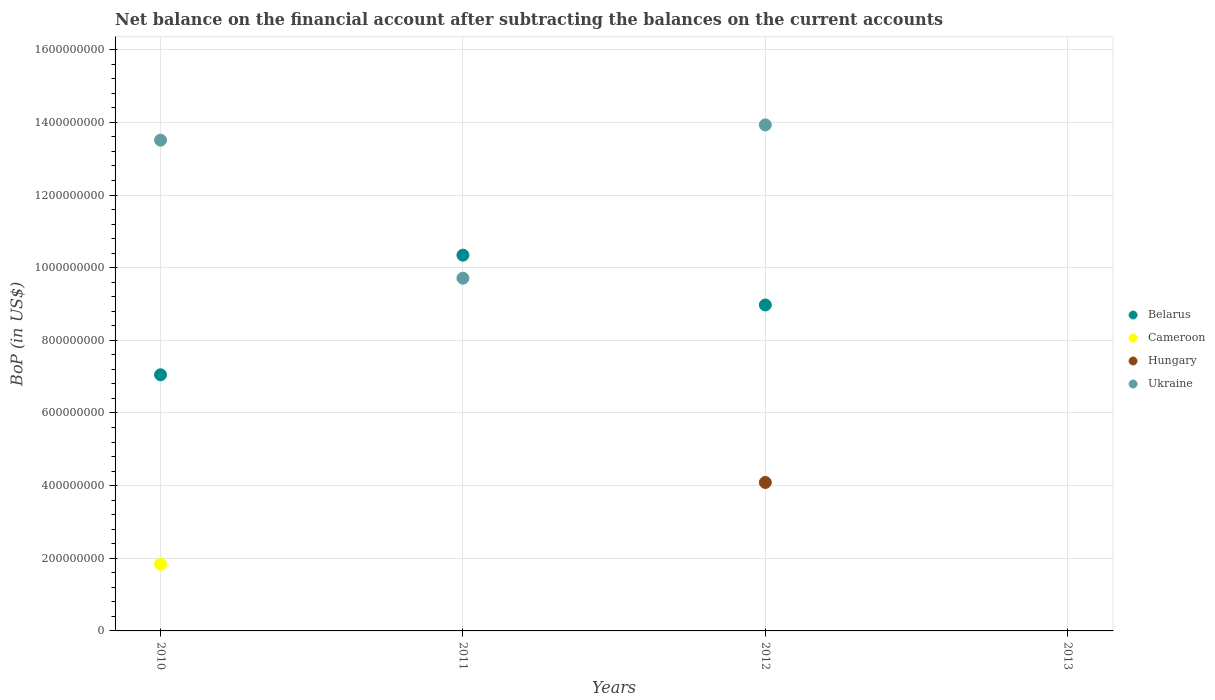What is the Balance of Payments in Hungary in 2010?
Your response must be concise. 0. Across all years, what is the maximum Balance of Payments in Cameroon?
Give a very brief answer. 1.84e+08. What is the total Balance of Payments in Belarus in the graph?
Offer a very short reply. 2.64e+09. What is the difference between the Balance of Payments in Ukraine in 2010 and that in 2011?
Your response must be concise. 3.80e+08. What is the difference between the Balance of Payments in Hungary in 2010 and the Balance of Payments in Belarus in 2012?
Offer a very short reply. -8.97e+08. What is the average Balance of Payments in Hungary per year?
Your response must be concise. 1.02e+08. In the year 2012, what is the difference between the Balance of Payments in Ukraine and Balance of Payments in Belarus?
Your answer should be compact. 4.96e+08. In how many years, is the Balance of Payments in Ukraine greater than 560000000 US$?
Keep it short and to the point. 3. Is the difference between the Balance of Payments in Ukraine in 2010 and 2012 greater than the difference between the Balance of Payments in Belarus in 2010 and 2012?
Give a very brief answer. Yes. What is the difference between the highest and the second highest Balance of Payments in Belarus?
Make the answer very short. 1.37e+08. What is the difference between the highest and the lowest Balance of Payments in Ukraine?
Give a very brief answer. 1.39e+09. Is the sum of the Balance of Payments in Ukraine in 2011 and 2012 greater than the maximum Balance of Payments in Belarus across all years?
Give a very brief answer. Yes. Does the Balance of Payments in Hungary monotonically increase over the years?
Keep it short and to the point. No. Is the Balance of Payments in Belarus strictly less than the Balance of Payments in Cameroon over the years?
Offer a very short reply. No. What is the difference between two consecutive major ticks on the Y-axis?
Ensure brevity in your answer.  2.00e+08. Are the values on the major ticks of Y-axis written in scientific E-notation?
Provide a short and direct response. No. Does the graph contain grids?
Provide a succinct answer. Yes. How many legend labels are there?
Ensure brevity in your answer.  4. What is the title of the graph?
Provide a short and direct response. Net balance on the financial account after subtracting the balances on the current accounts. Does "Suriname" appear as one of the legend labels in the graph?
Your response must be concise. No. What is the label or title of the X-axis?
Ensure brevity in your answer.  Years. What is the label or title of the Y-axis?
Your answer should be compact. BoP (in US$). What is the BoP (in US$) of Belarus in 2010?
Provide a short and direct response. 7.05e+08. What is the BoP (in US$) in Cameroon in 2010?
Provide a succinct answer. 1.84e+08. What is the BoP (in US$) of Hungary in 2010?
Ensure brevity in your answer.  0. What is the BoP (in US$) in Ukraine in 2010?
Keep it short and to the point. 1.35e+09. What is the BoP (in US$) in Belarus in 2011?
Keep it short and to the point. 1.03e+09. What is the BoP (in US$) of Cameroon in 2011?
Provide a short and direct response. 0. What is the BoP (in US$) in Ukraine in 2011?
Provide a succinct answer. 9.71e+08. What is the BoP (in US$) in Belarus in 2012?
Offer a very short reply. 8.97e+08. What is the BoP (in US$) in Hungary in 2012?
Ensure brevity in your answer.  4.09e+08. What is the BoP (in US$) of Ukraine in 2012?
Provide a succinct answer. 1.39e+09. What is the BoP (in US$) of Belarus in 2013?
Provide a succinct answer. 0. What is the BoP (in US$) of Cameroon in 2013?
Offer a very short reply. 0. What is the BoP (in US$) in Hungary in 2013?
Keep it short and to the point. 0. Across all years, what is the maximum BoP (in US$) in Belarus?
Offer a terse response. 1.03e+09. Across all years, what is the maximum BoP (in US$) in Cameroon?
Offer a very short reply. 1.84e+08. Across all years, what is the maximum BoP (in US$) in Hungary?
Provide a short and direct response. 4.09e+08. Across all years, what is the maximum BoP (in US$) in Ukraine?
Your answer should be compact. 1.39e+09. Across all years, what is the minimum BoP (in US$) in Belarus?
Offer a very short reply. 0. What is the total BoP (in US$) of Belarus in the graph?
Your answer should be very brief. 2.64e+09. What is the total BoP (in US$) of Cameroon in the graph?
Your answer should be very brief. 1.84e+08. What is the total BoP (in US$) in Hungary in the graph?
Give a very brief answer. 4.09e+08. What is the total BoP (in US$) of Ukraine in the graph?
Your answer should be compact. 3.72e+09. What is the difference between the BoP (in US$) in Belarus in 2010 and that in 2011?
Provide a succinct answer. -3.29e+08. What is the difference between the BoP (in US$) of Ukraine in 2010 and that in 2011?
Provide a succinct answer. 3.80e+08. What is the difference between the BoP (in US$) in Belarus in 2010 and that in 2012?
Provide a short and direct response. -1.92e+08. What is the difference between the BoP (in US$) in Ukraine in 2010 and that in 2012?
Ensure brevity in your answer.  -4.20e+07. What is the difference between the BoP (in US$) in Belarus in 2011 and that in 2012?
Your answer should be very brief. 1.37e+08. What is the difference between the BoP (in US$) of Ukraine in 2011 and that in 2012?
Offer a very short reply. -4.22e+08. What is the difference between the BoP (in US$) of Belarus in 2010 and the BoP (in US$) of Ukraine in 2011?
Give a very brief answer. -2.66e+08. What is the difference between the BoP (in US$) in Cameroon in 2010 and the BoP (in US$) in Ukraine in 2011?
Offer a very short reply. -7.87e+08. What is the difference between the BoP (in US$) of Belarus in 2010 and the BoP (in US$) of Hungary in 2012?
Make the answer very short. 2.96e+08. What is the difference between the BoP (in US$) of Belarus in 2010 and the BoP (in US$) of Ukraine in 2012?
Your answer should be compact. -6.88e+08. What is the difference between the BoP (in US$) in Cameroon in 2010 and the BoP (in US$) in Hungary in 2012?
Ensure brevity in your answer.  -2.25e+08. What is the difference between the BoP (in US$) of Cameroon in 2010 and the BoP (in US$) of Ukraine in 2012?
Ensure brevity in your answer.  -1.21e+09. What is the difference between the BoP (in US$) in Belarus in 2011 and the BoP (in US$) in Hungary in 2012?
Keep it short and to the point. 6.26e+08. What is the difference between the BoP (in US$) in Belarus in 2011 and the BoP (in US$) in Ukraine in 2012?
Your answer should be compact. -3.59e+08. What is the average BoP (in US$) of Belarus per year?
Provide a succinct answer. 6.59e+08. What is the average BoP (in US$) of Cameroon per year?
Your response must be concise. 4.59e+07. What is the average BoP (in US$) of Hungary per year?
Make the answer very short. 1.02e+08. What is the average BoP (in US$) in Ukraine per year?
Your response must be concise. 9.29e+08. In the year 2010, what is the difference between the BoP (in US$) of Belarus and BoP (in US$) of Cameroon?
Your answer should be very brief. 5.21e+08. In the year 2010, what is the difference between the BoP (in US$) in Belarus and BoP (in US$) in Ukraine?
Keep it short and to the point. -6.46e+08. In the year 2010, what is the difference between the BoP (in US$) in Cameroon and BoP (in US$) in Ukraine?
Give a very brief answer. -1.17e+09. In the year 2011, what is the difference between the BoP (in US$) of Belarus and BoP (in US$) of Ukraine?
Your answer should be very brief. 6.34e+07. In the year 2012, what is the difference between the BoP (in US$) in Belarus and BoP (in US$) in Hungary?
Offer a very short reply. 4.89e+08. In the year 2012, what is the difference between the BoP (in US$) of Belarus and BoP (in US$) of Ukraine?
Your response must be concise. -4.96e+08. In the year 2012, what is the difference between the BoP (in US$) in Hungary and BoP (in US$) in Ukraine?
Offer a terse response. -9.84e+08. What is the ratio of the BoP (in US$) of Belarus in 2010 to that in 2011?
Make the answer very short. 0.68. What is the ratio of the BoP (in US$) of Ukraine in 2010 to that in 2011?
Your answer should be very brief. 1.39. What is the ratio of the BoP (in US$) of Belarus in 2010 to that in 2012?
Your answer should be very brief. 0.79. What is the ratio of the BoP (in US$) in Ukraine in 2010 to that in 2012?
Give a very brief answer. 0.97. What is the ratio of the BoP (in US$) in Belarus in 2011 to that in 2012?
Your answer should be compact. 1.15. What is the ratio of the BoP (in US$) of Ukraine in 2011 to that in 2012?
Offer a very short reply. 0.7. What is the difference between the highest and the second highest BoP (in US$) in Belarus?
Your answer should be compact. 1.37e+08. What is the difference between the highest and the second highest BoP (in US$) in Ukraine?
Ensure brevity in your answer.  4.20e+07. What is the difference between the highest and the lowest BoP (in US$) of Belarus?
Make the answer very short. 1.03e+09. What is the difference between the highest and the lowest BoP (in US$) in Cameroon?
Make the answer very short. 1.84e+08. What is the difference between the highest and the lowest BoP (in US$) of Hungary?
Provide a short and direct response. 4.09e+08. What is the difference between the highest and the lowest BoP (in US$) in Ukraine?
Offer a terse response. 1.39e+09. 